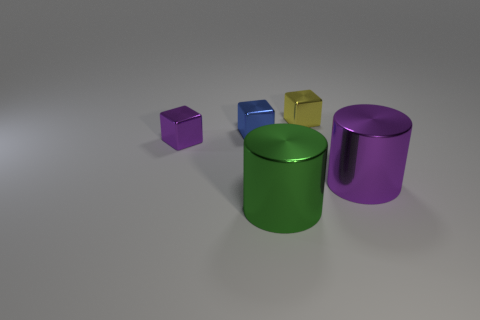Add 3 red cubes. How many objects exist? 8 Subtract all cylinders. How many objects are left? 3 Subtract 0 gray balls. How many objects are left? 5 Subtract all large purple metal cylinders. Subtract all big brown metal things. How many objects are left? 4 Add 5 purple blocks. How many purple blocks are left? 6 Add 5 blue things. How many blue things exist? 6 